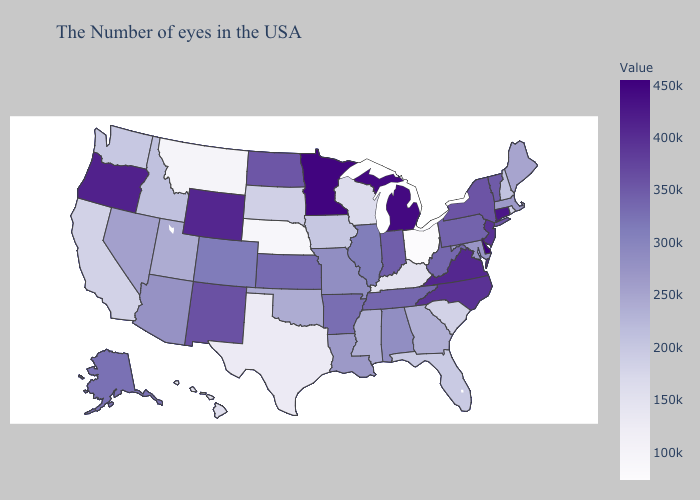Does Delaware have the highest value in the USA?
Quick response, please. Yes. Which states have the lowest value in the USA?
Answer briefly. Ohio. Does Ohio have the lowest value in the MidWest?
Keep it brief. Yes. Which states hav the highest value in the West?
Be succinct. Oregon. Among the states that border Maryland , does Delaware have the highest value?
Quick response, please. Yes. Is the legend a continuous bar?
Answer briefly. Yes. Does Rhode Island have the lowest value in the Northeast?
Answer briefly. Yes. 